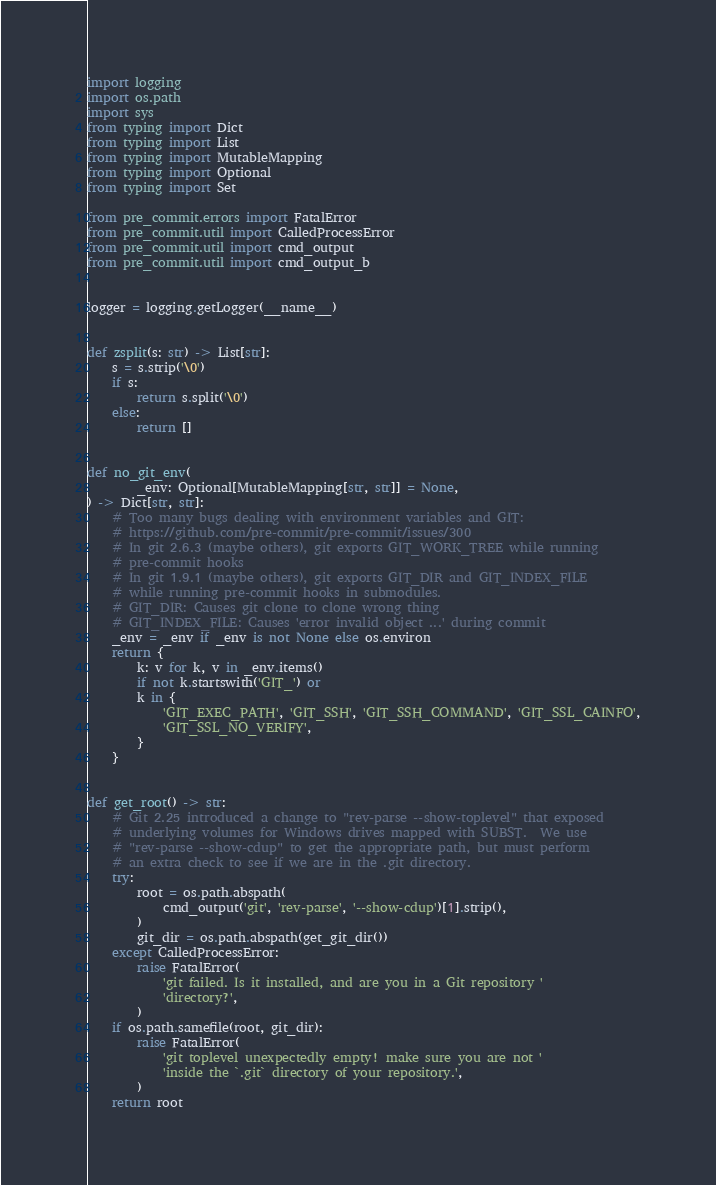Convert code to text. <code><loc_0><loc_0><loc_500><loc_500><_Python_>import logging
import os.path
import sys
from typing import Dict
from typing import List
from typing import MutableMapping
from typing import Optional
from typing import Set

from pre_commit.errors import FatalError
from pre_commit.util import CalledProcessError
from pre_commit.util import cmd_output
from pre_commit.util import cmd_output_b


logger = logging.getLogger(__name__)


def zsplit(s: str) -> List[str]:
    s = s.strip('\0')
    if s:
        return s.split('\0')
    else:
        return []


def no_git_env(
        _env: Optional[MutableMapping[str, str]] = None,
) -> Dict[str, str]:
    # Too many bugs dealing with environment variables and GIT:
    # https://github.com/pre-commit/pre-commit/issues/300
    # In git 2.6.3 (maybe others), git exports GIT_WORK_TREE while running
    # pre-commit hooks
    # In git 1.9.1 (maybe others), git exports GIT_DIR and GIT_INDEX_FILE
    # while running pre-commit hooks in submodules.
    # GIT_DIR: Causes git clone to clone wrong thing
    # GIT_INDEX_FILE: Causes 'error invalid object ...' during commit
    _env = _env if _env is not None else os.environ
    return {
        k: v for k, v in _env.items()
        if not k.startswith('GIT_') or
        k in {
            'GIT_EXEC_PATH', 'GIT_SSH', 'GIT_SSH_COMMAND', 'GIT_SSL_CAINFO',
            'GIT_SSL_NO_VERIFY',
        }
    }


def get_root() -> str:
    # Git 2.25 introduced a change to "rev-parse --show-toplevel" that exposed
    # underlying volumes for Windows drives mapped with SUBST.  We use
    # "rev-parse --show-cdup" to get the appropriate path, but must perform
    # an extra check to see if we are in the .git directory.
    try:
        root = os.path.abspath(
            cmd_output('git', 'rev-parse', '--show-cdup')[1].strip(),
        )
        git_dir = os.path.abspath(get_git_dir())
    except CalledProcessError:
        raise FatalError(
            'git failed. Is it installed, and are you in a Git repository '
            'directory?',
        )
    if os.path.samefile(root, git_dir):
        raise FatalError(
            'git toplevel unexpectedly empty! make sure you are not '
            'inside the `.git` directory of your repository.',
        )
    return root

</code> 